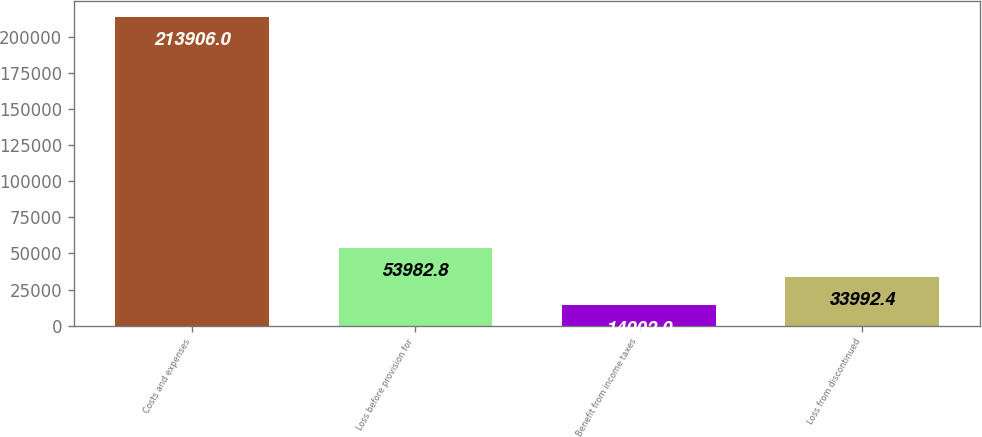Convert chart to OTSL. <chart><loc_0><loc_0><loc_500><loc_500><bar_chart><fcel>Costs and expenses<fcel>Loss before provision for<fcel>Benefit from income taxes<fcel>Loss from discontinued<nl><fcel>213906<fcel>53982.8<fcel>14002<fcel>33992.4<nl></chart> 